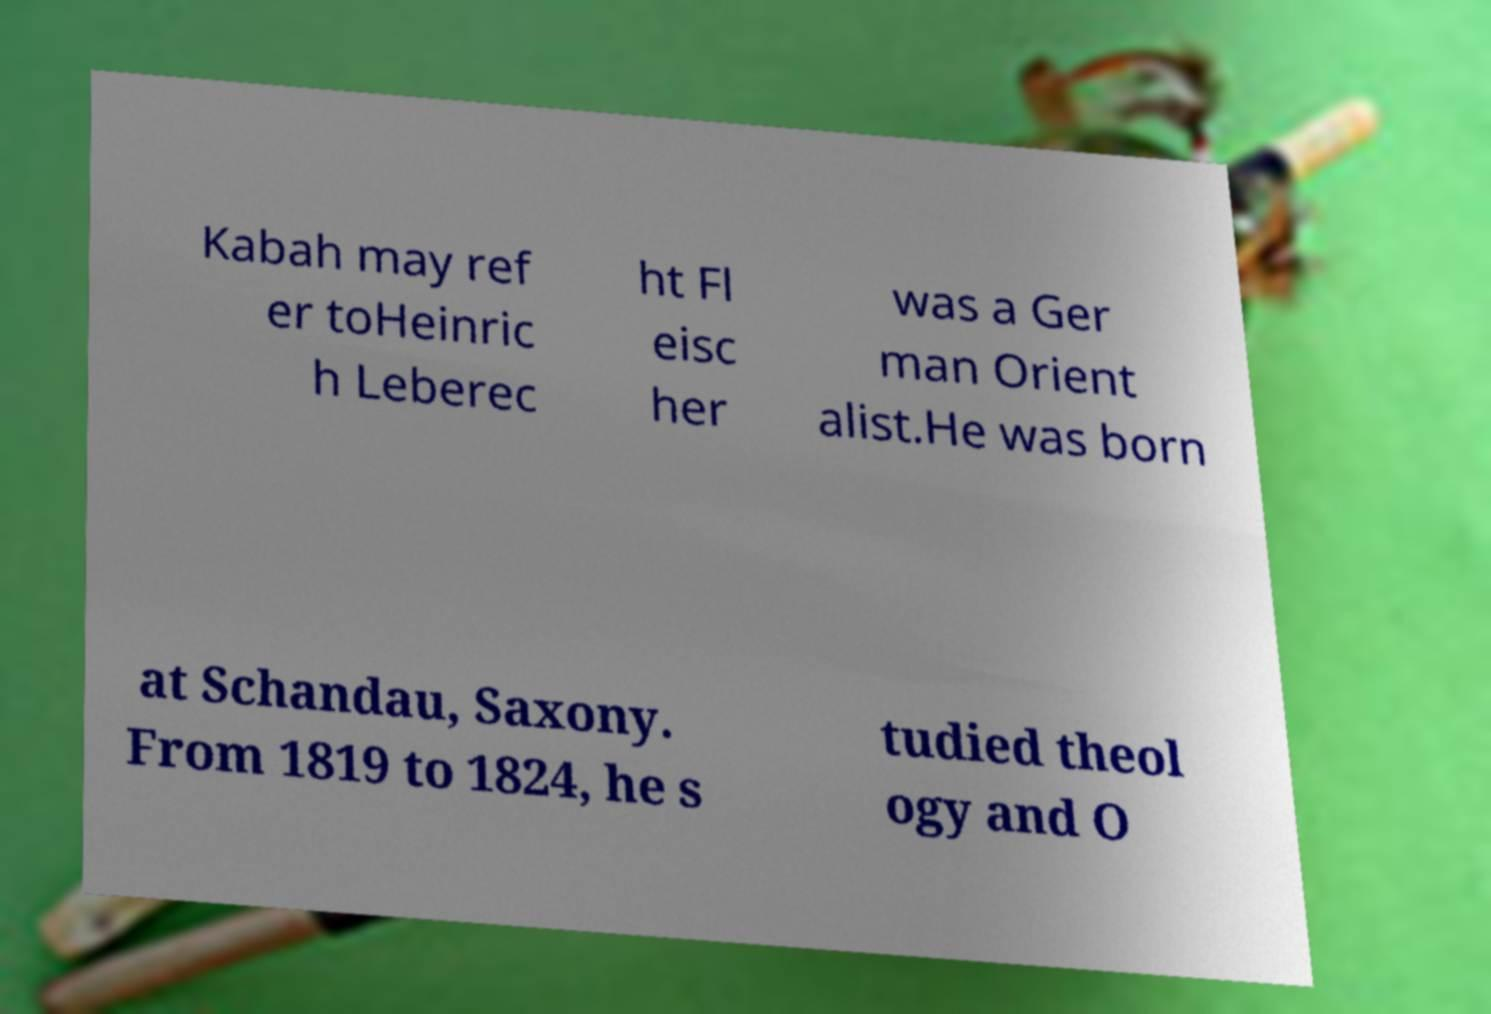Please identify and transcribe the text found in this image. Kabah may ref er toHeinric h Leberec ht Fl eisc her was a Ger man Orient alist.He was born at Schandau, Saxony. From 1819 to 1824, he s tudied theol ogy and O 